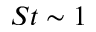Convert formula to latex. <formula><loc_0><loc_0><loc_500><loc_500>S t \sim 1</formula> 